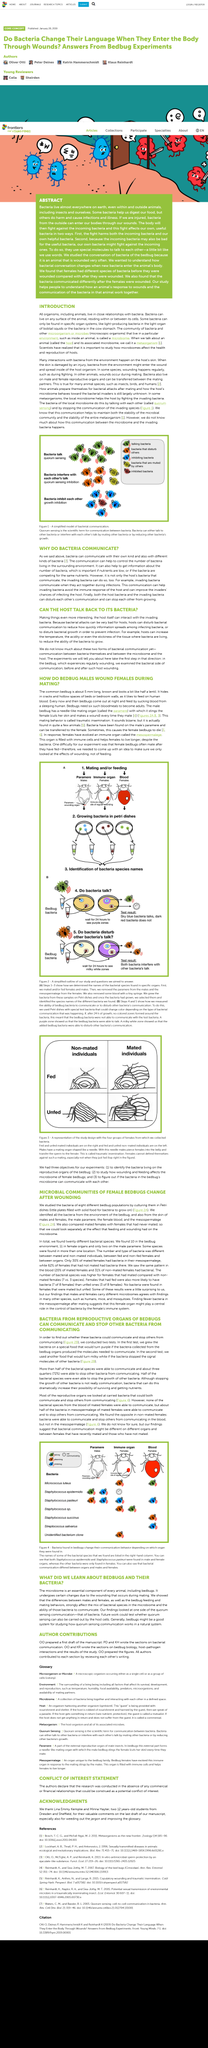Point out several critical features in this image. Scientists used a specific type of surface to isolate microbial communities of bedbugs, which were then cultured on Petri dishes. It is uncertain whether quorum sensing can also be carried out by the host cells. This study considered the mating status of female bedbugs and compared the outcomes for both mated and unmated bedbugs. The study aimed to determine if bacteria could communicate and stop others from communicating. Two (2) tests were conducted to achieve this objective. The results of the test showed that seventy-two percent (72%) of the bacteria in the sample were able to prevent other bacteria from communicating. 